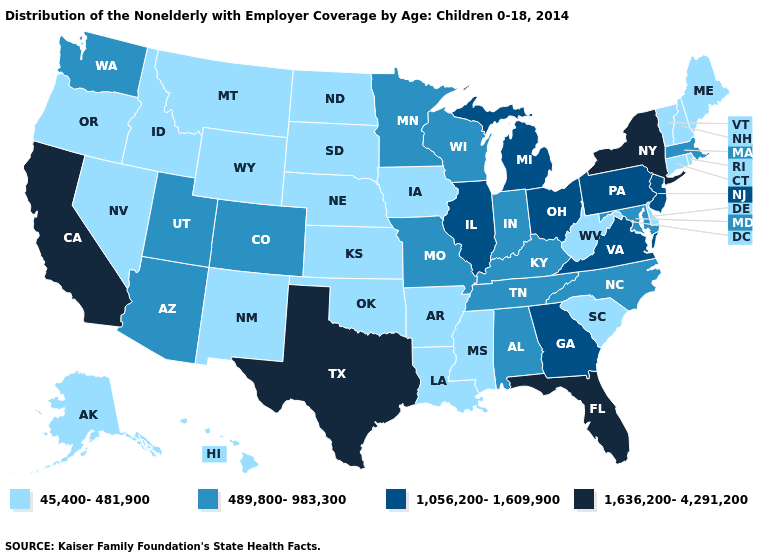What is the value of Virginia?
Short answer required. 1,056,200-1,609,900. Which states have the lowest value in the Northeast?
Quick response, please. Connecticut, Maine, New Hampshire, Rhode Island, Vermont. Does Kansas have the highest value in the MidWest?
Concise answer only. No. What is the highest value in the MidWest ?
Answer briefly. 1,056,200-1,609,900. Name the states that have a value in the range 45,400-481,900?
Short answer required. Alaska, Arkansas, Connecticut, Delaware, Hawaii, Idaho, Iowa, Kansas, Louisiana, Maine, Mississippi, Montana, Nebraska, Nevada, New Hampshire, New Mexico, North Dakota, Oklahoma, Oregon, Rhode Island, South Carolina, South Dakota, Vermont, West Virginia, Wyoming. Does Iowa have the lowest value in the MidWest?
Short answer required. Yes. What is the lowest value in the USA?
Concise answer only. 45,400-481,900. Among the states that border Washington , which have the lowest value?
Quick response, please. Idaho, Oregon. What is the value of Kentucky?
Give a very brief answer. 489,800-983,300. Name the states that have a value in the range 45,400-481,900?
Give a very brief answer. Alaska, Arkansas, Connecticut, Delaware, Hawaii, Idaho, Iowa, Kansas, Louisiana, Maine, Mississippi, Montana, Nebraska, Nevada, New Hampshire, New Mexico, North Dakota, Oklahoma, Oregon, Rhode Island, South Carolina, South Dakota, Vermont, West Virginia, Wyoming. Name the states that have a value in the range 1,056,200-1,609,900?
Answer briefly. Georgia, Illinois, Michigan, New Jersey, Ohio, Pennsylvania, Virginia. Name the states that have a value in the range 1,056,200-1,609,900?
Quick response, please. Georgia, Illinois, Michigan, New Jersey, Ohio, Pennsylvania, Virginia. Name the states that have a value in the range 1,636,200-4,291,200?
Concise answer only. California, Florida, New York, Texas. Name the states that have a value in the range 1,056,200-1,609,900?
Concise answer only. Georgia, Illinois, Michigan, New Jersey, Ohio, Pennsylvania, Virginia. 